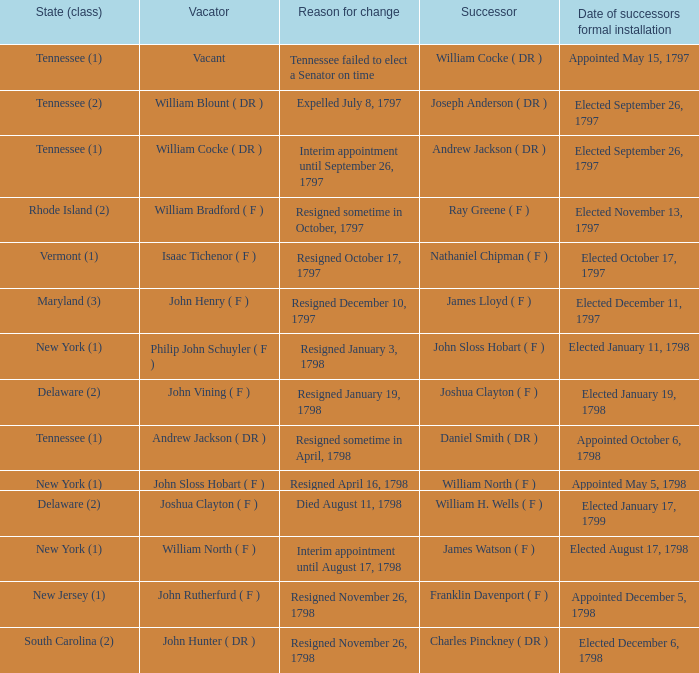What is the count of vacators when the subsequent person was william h. wells (f)? 1.0. 